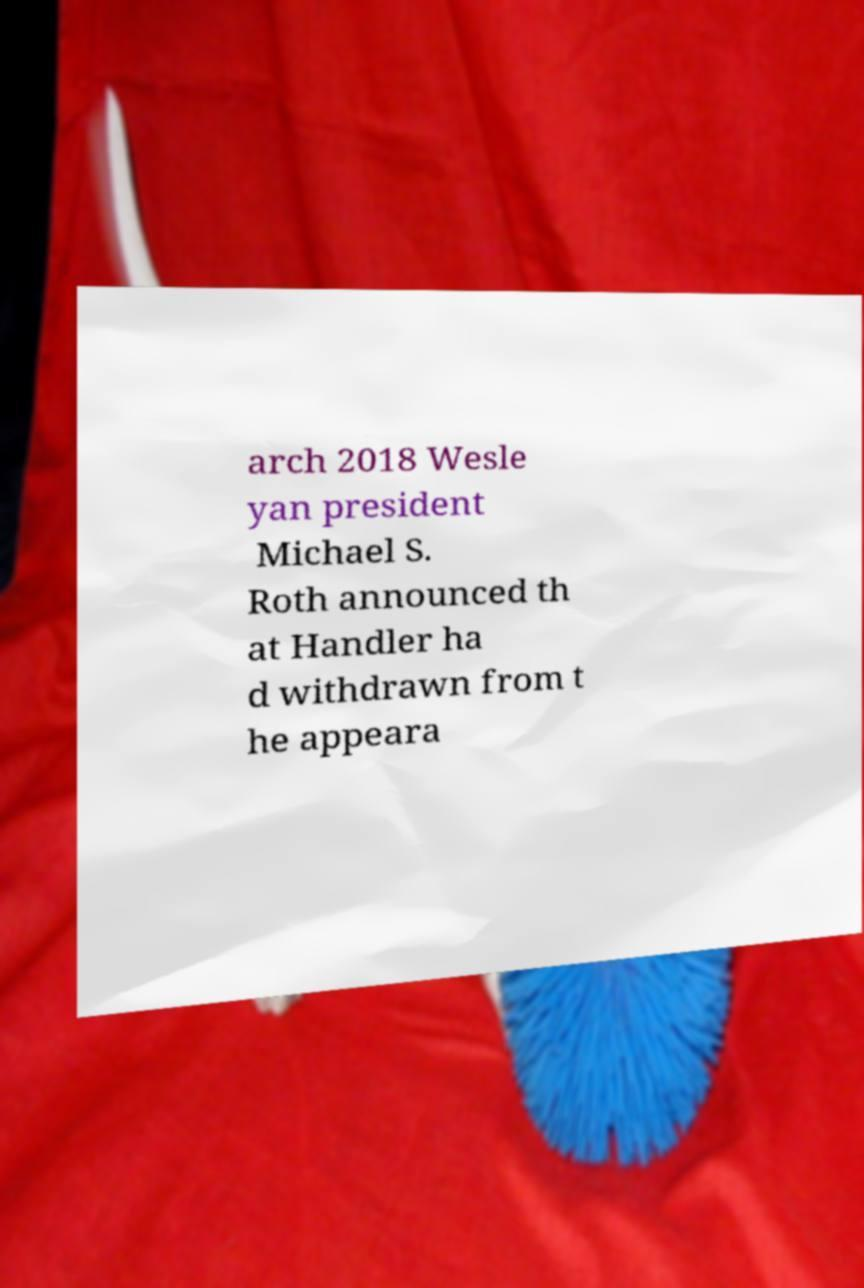Can you read and provide the text displayed in the image?This photo seems to have some interesting text. Can you extract and type it out for me? arch 2018 Wesle yan president Michael S. Roth announced th at Handler ha d withdrawn from t he appeara 